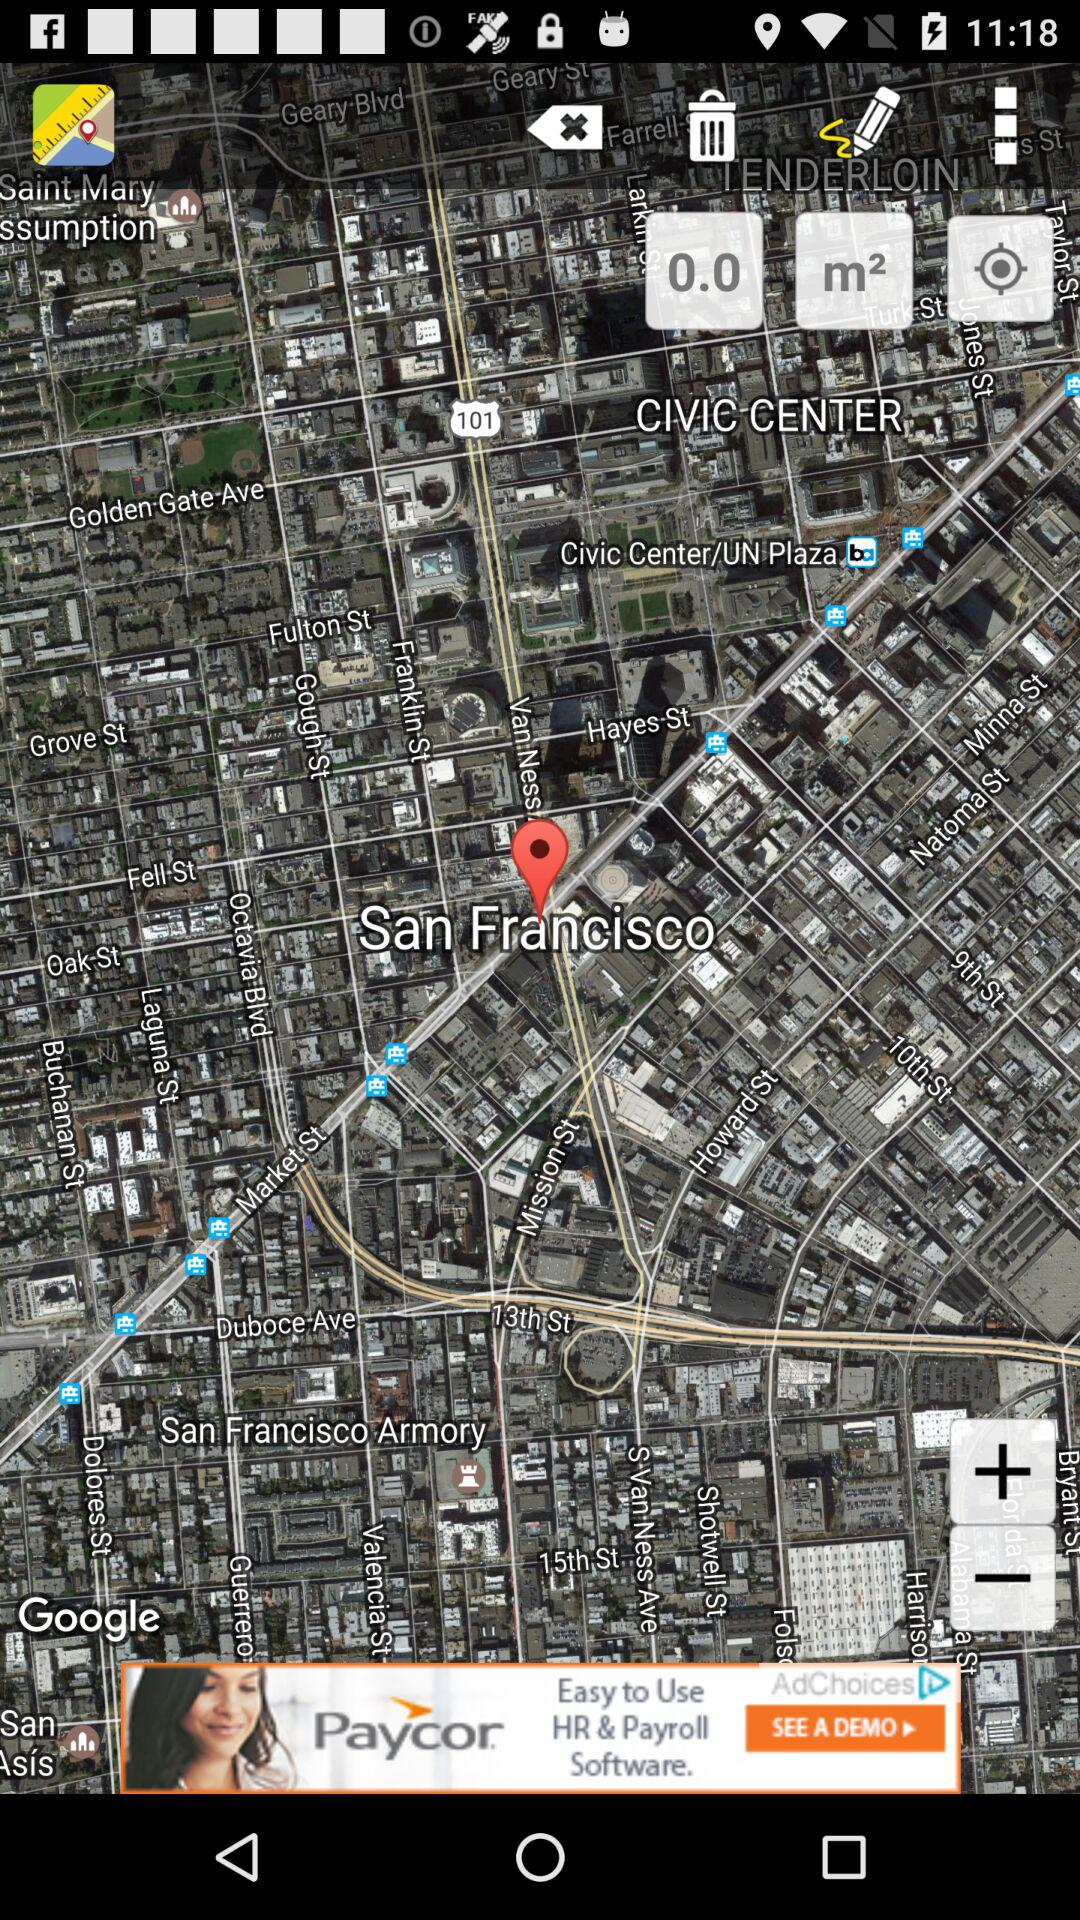Which country is pinpoint on?
When the provided information is insufficient, respond with <no answer>. <no answer> 